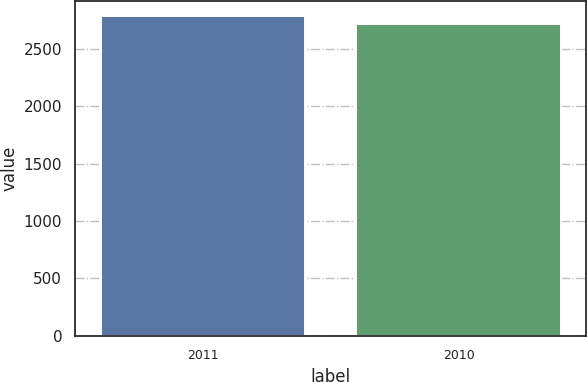<chart> <loc_0><loc_0><loc_500><loc_500><bar_chart><fcel>2011<fcel>2010<nl><fcel>2781<fcel>2717<nl></chart> 